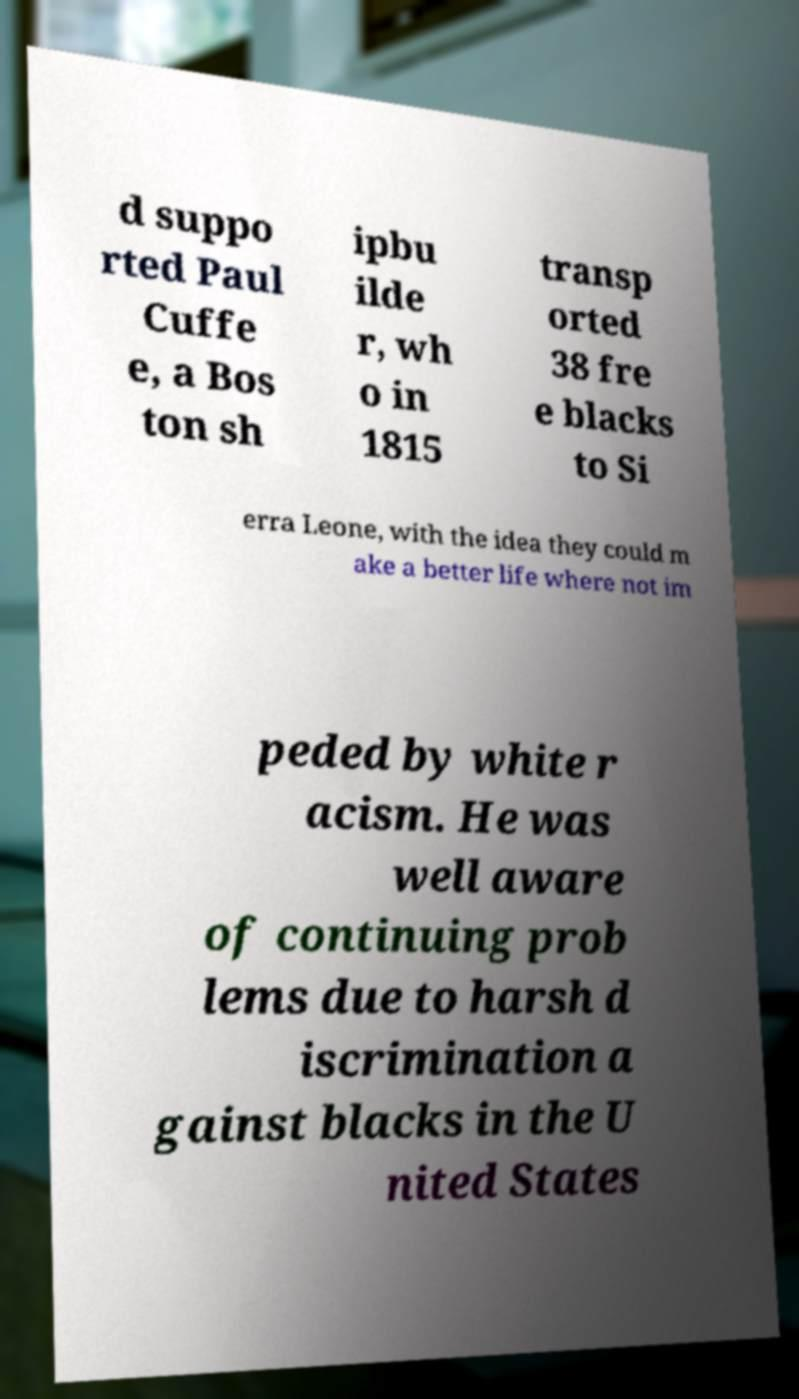Could you extract and type out the text from this image? d suppo rted Paul Cuffe e, a Bos ton sh ipbu ilde r, wh o in 1815 transp orted 38 fre e blacks to Si erra Leone, with the idea they could m ake a better life where not im peded by white r acism. He was well aware of continuing prob lems due to harsh d iscrimination a gainst blacks in the U nited States 